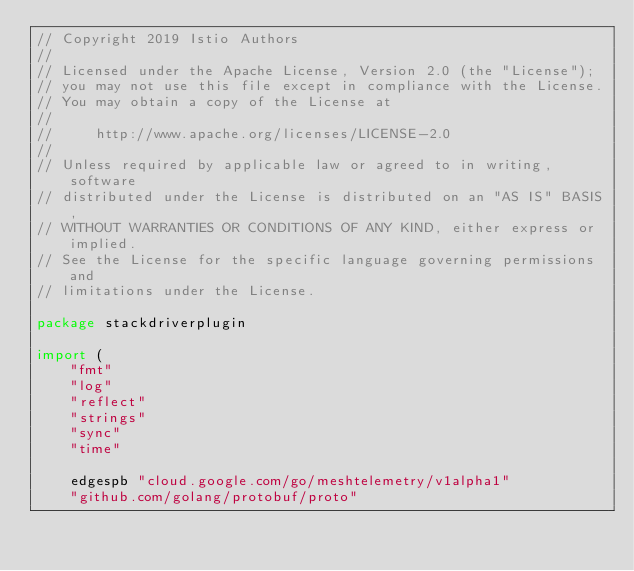Convert code to text. <code><loc_0><loc_0><loc_500><loc_500><_Go_>// Copyright 2019 Istio Authors
//
// Licensed under the Apache License, Version 2.0 (the "License");
// you may not use this file except in compliance with the License.
// You may obtain a copy of the License at
//
//     http://www.apache.org/licenses/LICENSE-2.0
//
// Unless required by applicable law or agreed to in writing, software
// distributed under the License is distributed on an "AS IS" BASIS,
// WITHOUT WARRANTIES OR CONDITIONS OF ANY KIND, either express or implied.
// See the License for the specific language governing permissions and
// limitations under the License.

package stackdriverplugin

import (
	"fmt"
	"log"
	"reflect"
	"strings"
	"sync"
	"time"

	edgespb "cloud.google.com/go/meshtelemetry/v1alpha1"
	"github.com/golang/protobuf/proto"</code> 